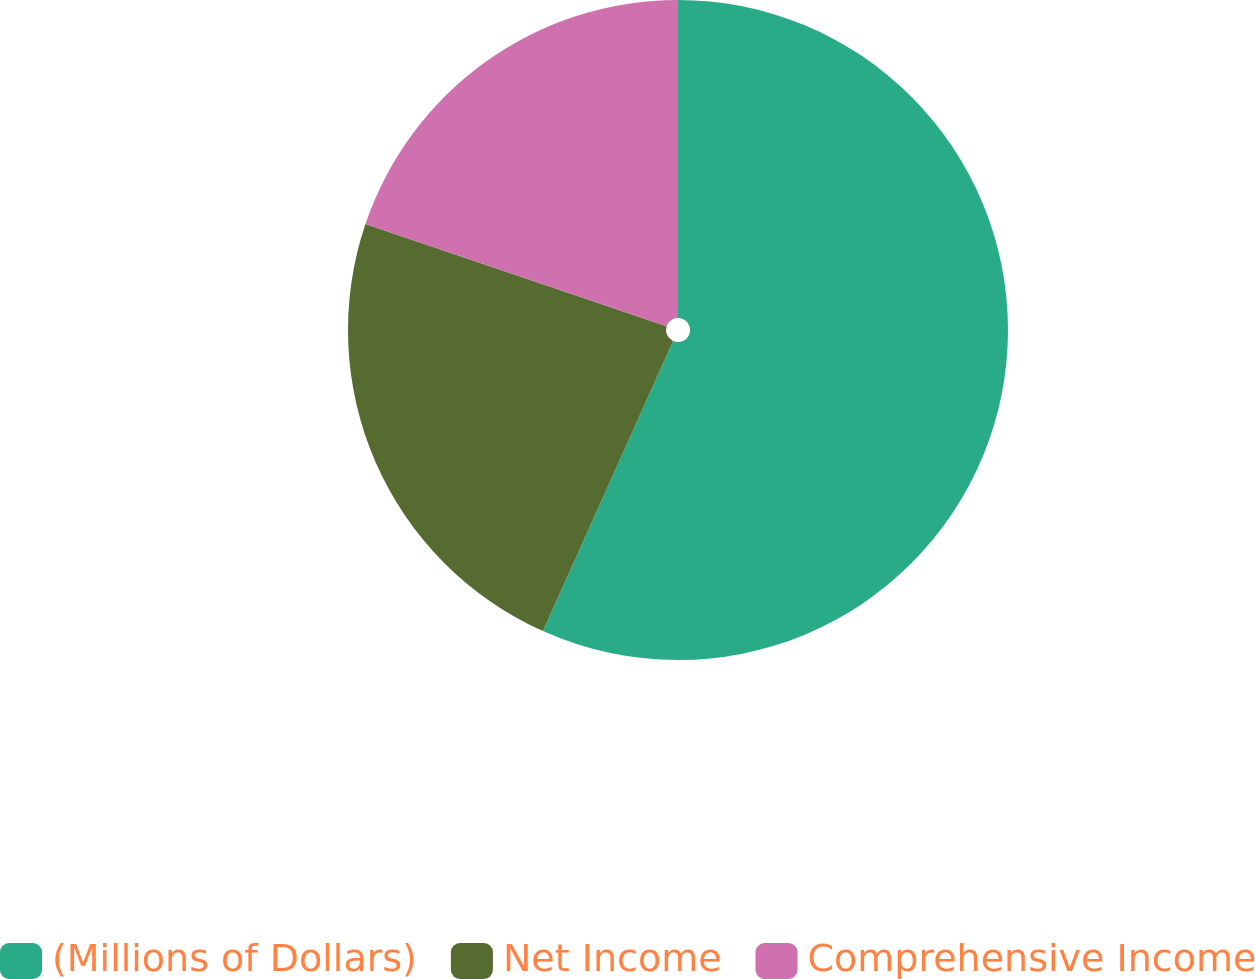Convert chart to OTSL. <chart><loc_0><loc_0><loc_500><loc_500><pie_chart><fcel>(Millions of Dollars)<fcel>Net Income<fcel>Comprehensive Income<nl><fcel>56.71%<fcel>23.49%<fcel>19.8%<nl></chart> 